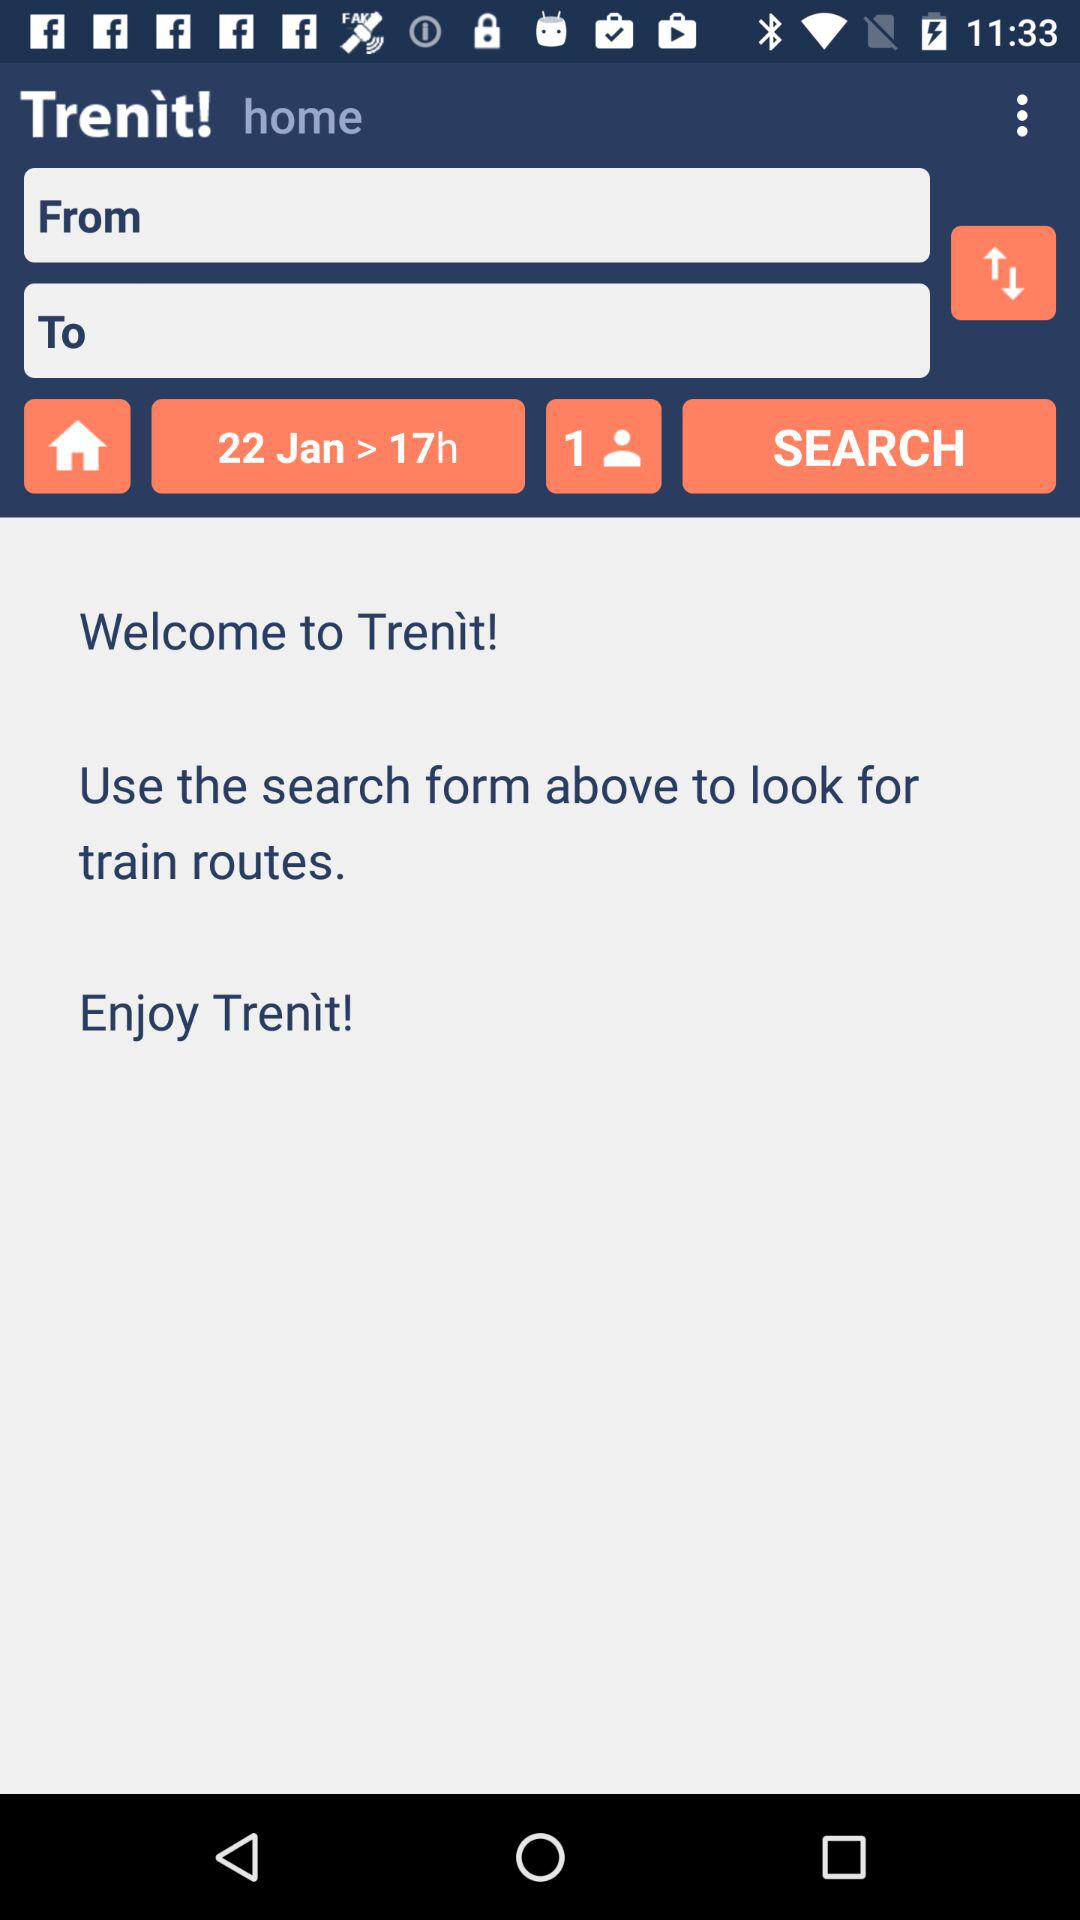What's the number of passengers? There is 1 passenger. 